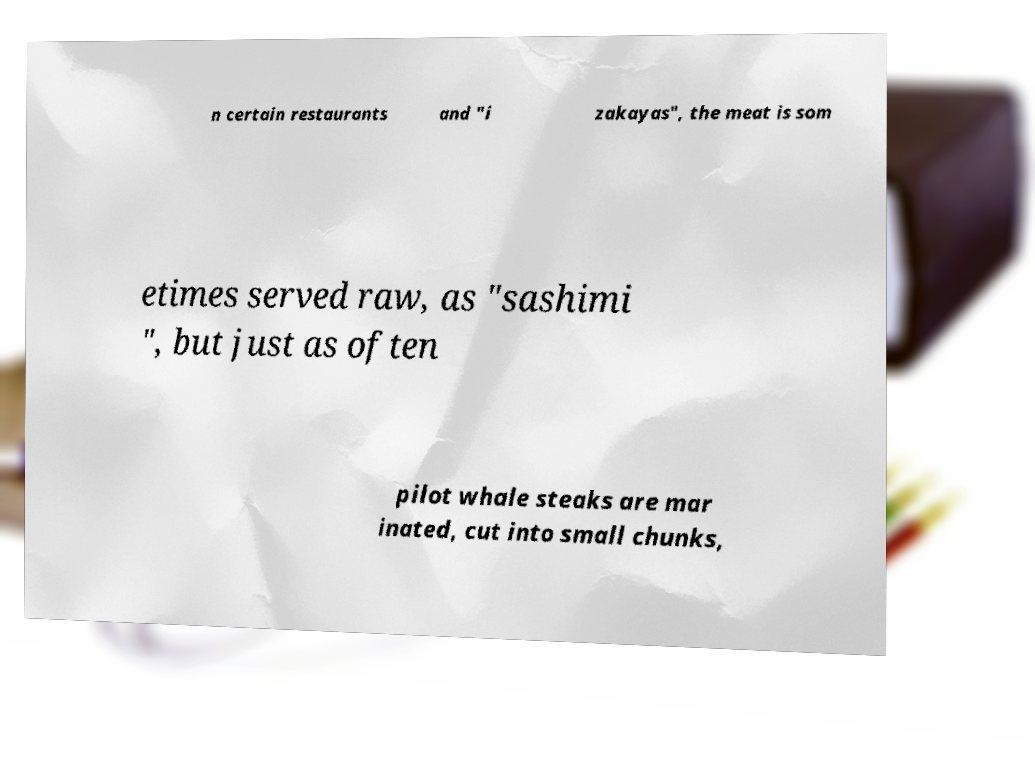There's text embedded in this image that I need extracted. Can you transcribe it verbatim? n certain restaurants and "i zakayas", the meat is som etimes served raw, as "sashimi ", but just as often pilot whale steaks are mar inated, cut into small chunks, 